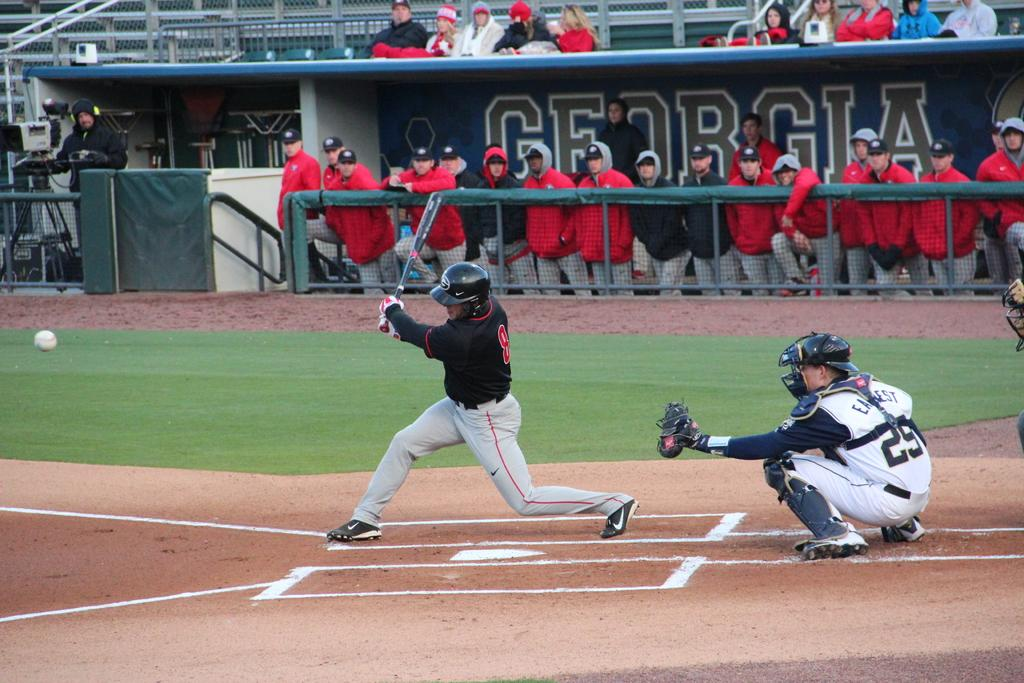<image>
Relay a brief, clear account of the picture shown. People playing baseball in a Georgia stadium outside 